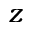Convert formula to latex. <formula><loc_0><loc_0><loc_500><loc_500>z</formula> 